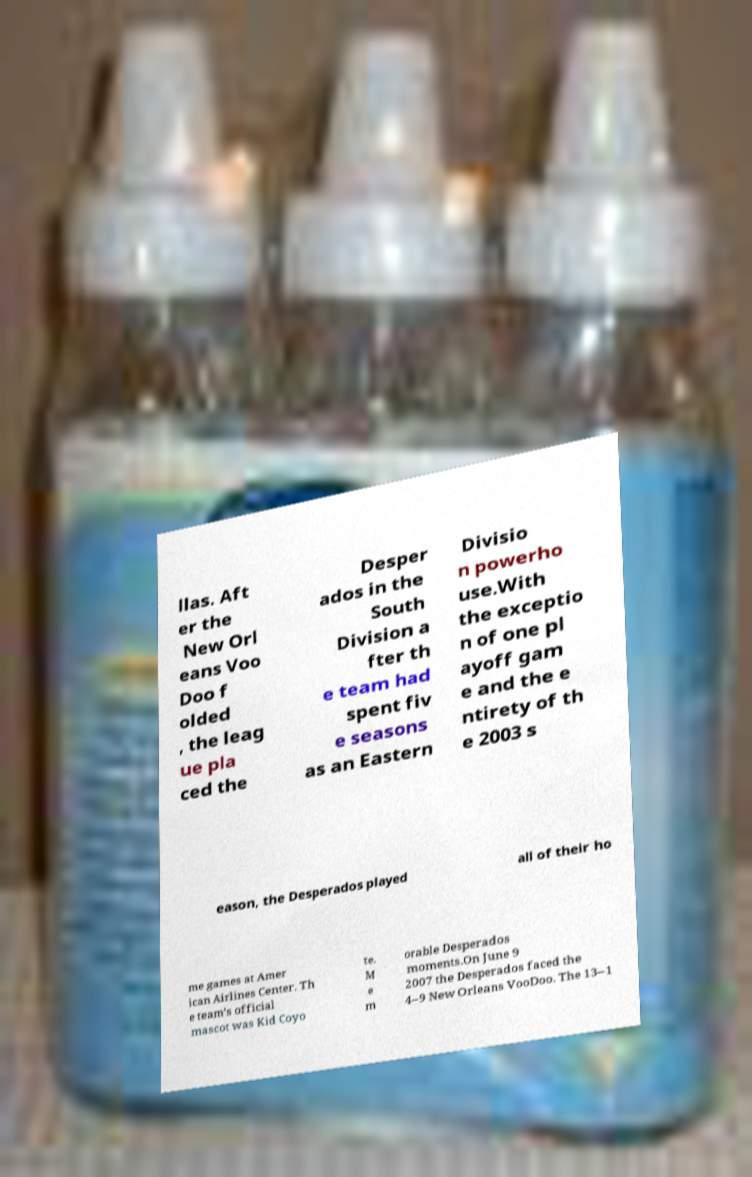Could you extract and type out the text from this image? llas. Aft er the New Orl eans Voo Doo f olded , the leag ue pla ced the Desper ados in the South Division a fter th e team had spent fiv e seasons as an Eastern Divisio n powerho use.With the exceptio n of one pl ayoff gam e and the e ntirety of th e 2003 s eason, the Desperados played all of their ho me games at Amer ican Airlines Center. Th e team’s official mascot was Kid Coyo te. M e m orable Desperados moments.On June 9 2007 the Desperados faced the 4–9 New Orleans VooDoo. The 13–1 